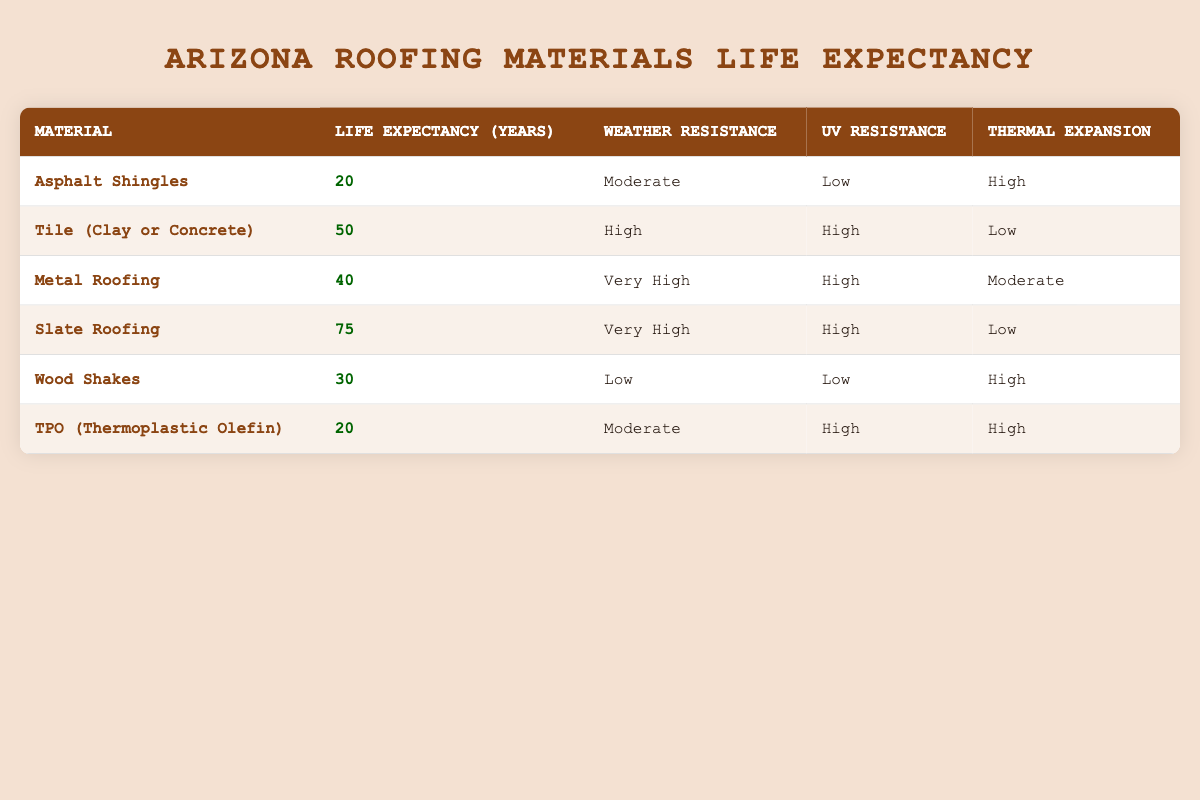What is the average life expectancy of all roofing materials listed? We sum the average life expectancies of all materials: (20 + 50 + 40 + 75 + 30 + 20) = 235. There are 6 materials, so we divide 235 by 6. The average is 235/6 = approximately 39.17.
Answer: 39.17 Which roofing material has the longest life expectancy? By inspecting the table, we see that Slate Roofing has the highest life expectancy of 75 years.
Answer: Slate Roofing How many roofing materials have a weather resistance rated as "High" or better? We review the table and find that Tile (Clay or Concrete), Metal Roofing, and Slate Roofing fall under the categories of "High" or "Very High" weather resistance. This gives us a total of 3 materials.
Answer: 3 Is it true that TPO roofing has a higher average life expectancy than Asphalt Shingles? Checking the average life expectancies, TPO is 20 years and Asphalt Shingles is 20 years. Therefore, TPO does not have a higher life expectancy, so the statement is false.
Answer: No What is the difference in average life expectancy between Slate Roofing and Wood Shakes? The average life expectancy for Slate Roofing is 75 years, while for Wood Shakes it is 30 years. The difference is 75 - 30 = 45 years.
Answer: 45 Which roofing material has the lowest UV resistance rating? The table shows that both Asphalt Shingles and Wood Shakes have a "Low" UV resistance rating, but we need to verify which one has the lowest overall rank. Since both are equal, we conclude that both share this distinction.
Answer: Asphalt Shingles and Wood Shakes How many roofing materials have "High" thermal expansion? From the table, Asphalt Shingles, Wood Shakes, and TPO materials are marked as having "High" thermal expansion. Counting them gives us a total of 3 materials.
Answer: 3 If I wanted to choose a roofing material based on both weather resistance and life expectancy, which material is the best option? By examining both columns, Slate Roofing has a life expectancy of 75 years and a "Very High" weather resistance. Therefore, it stands out as the best option considering both factors.
Answer: Slate Roofing 